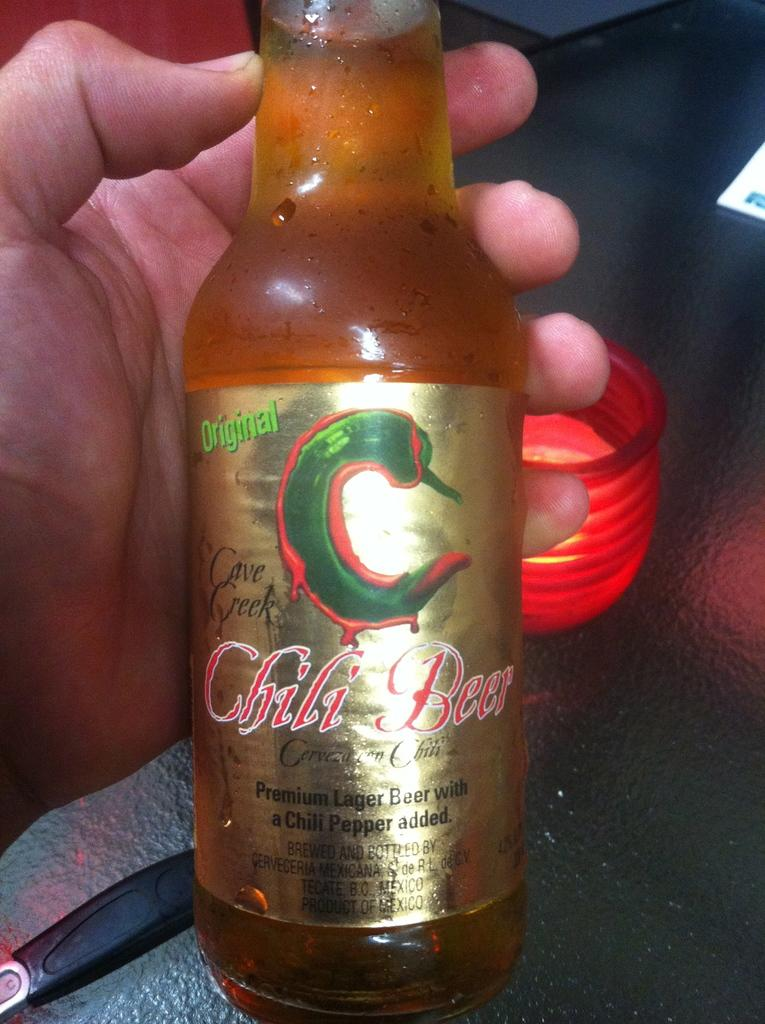Provide a one-sentence caption for the provided image. A hand holding a bottle of Chili Beer with a pepper pictured on it. 